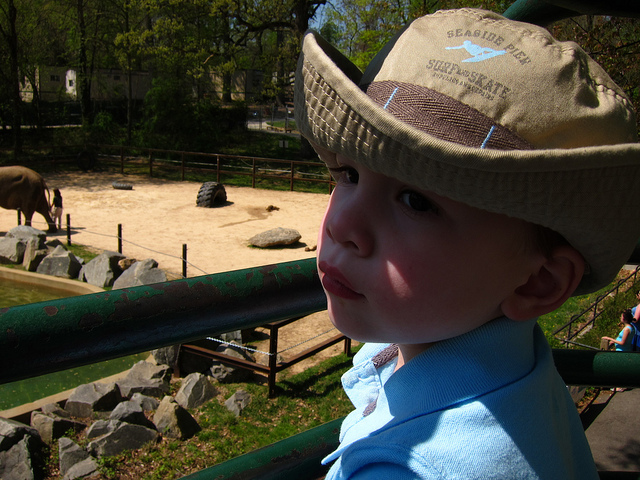Extract all visible text content from this image. SEASIDE PIEK SURF sKATE 